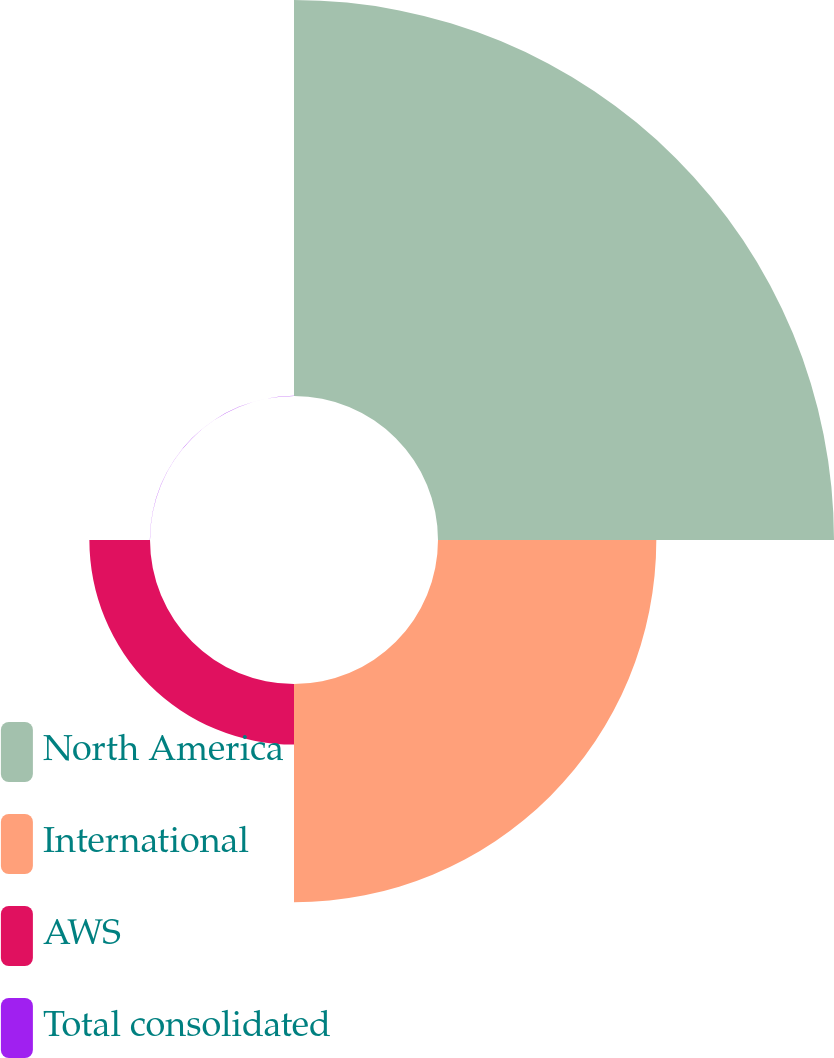<chart> <loc_0><loc_0><loc_500><loc_500><pie_chart><fcel>North America<fcel>International<fcel>AWS<fcel>Total consolidated<nl><fcel>58.66%<fcel>32.34%<fcel>8.98%<fcel>0.02%<nl></chart> 